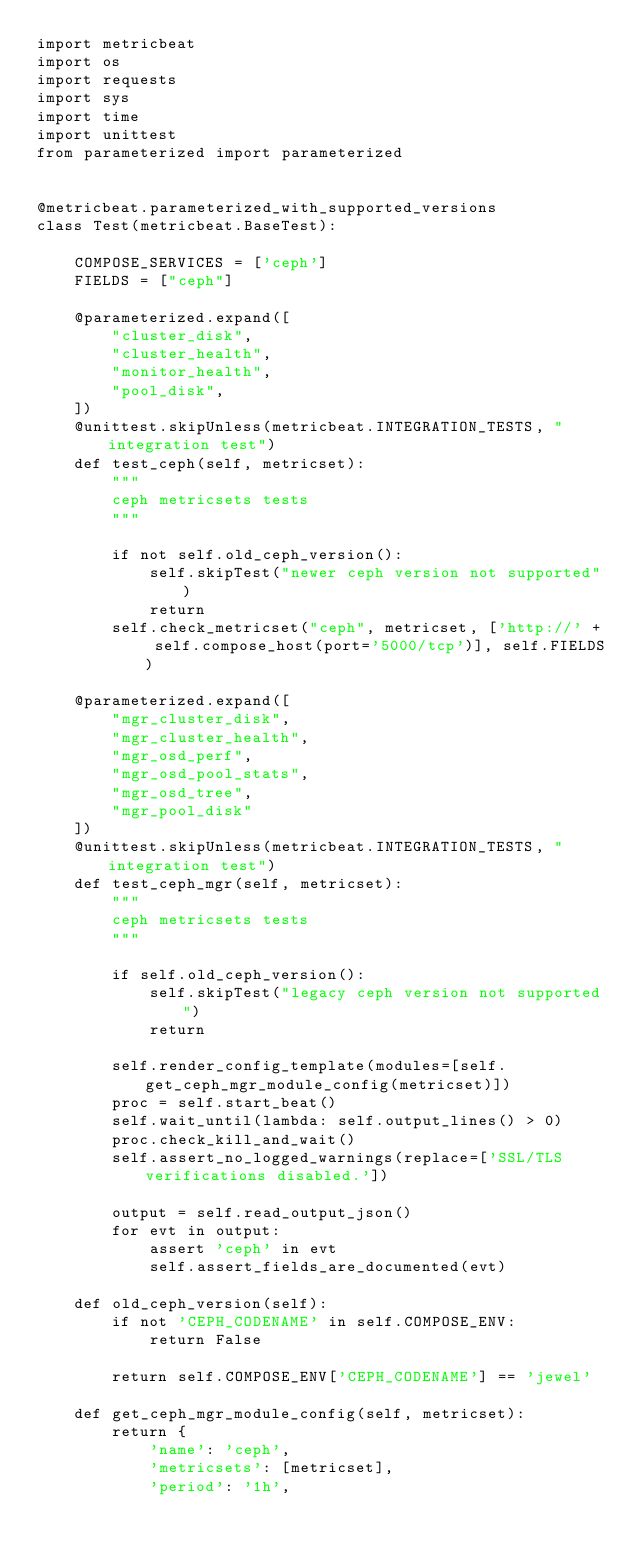Convert code to text. <code><loc_0><loc_0><loc_500><loc_500><_Python_>import metricbeat
import os
import requests
import sys
import time
import unittest
from parameterized import parameterized


@metricbeat.parameterized_with_supported_versions
class Test(metricbeat.BaseTest):

    COMPOSE_SERVICES = ['ceph']
    FIELDS = ["ceph"]

    @parameterized.expand([
        "cluster_disk",
        "cluster_health",
        "monitor_health",
        "pool_disk",
    ])
    @unittest.skipUnless(metricbeat.INTEGRATION_TESTS, "integration test")
    def test_ceph(self, metricset):
        """
        ceph metricsets tests
        """

        if not self.old_ceph_version():
            self.skipTest("newer ceph version not supported")
            return
        self.check_metricset("ceph", metricset, ['http://' + self.compose_host(port='5000/tcp')], self.FIELDS)

    @parameterized.expand([
        "mgr_cluster_disk",
        "mgr_cluster_health",
        "mgr_osd_perf",
        "mgr_osd_pool_stats",
        "mgr_osd_tree",
        "mgr_pool_disk"
    ])
    @unittest.skipUnless(metricbeat.INTEGRATION_TESTS, "integration test")
    def test_ceph_mgr(self, metricset):
        """
        ceph metricsets tests
        """

        if self.old_ceph_version():
            self.skipTest("legacy ceph version not supported")
            return

        self.render_config_template(modules=[self.get_ceph_mgr_module_config(metricset)])
        proc = self.start_beat()
        self.wait_until(lambda: self.output_lines() > 0)
        proc.check_kill_and_wait()
        self.assert_no_logged_warnings(replace=['SSL/TLS verifications disabled.'])

        output = self.read_output_json()
        for evt in output:
            assert 'ceph' in evt
            self.assert_fields_are_documented(evt)

    def old_ceph_version(self):
        if not 'CEPH_CODENAME' in self.COMPOSE_ENV:
            return False

        return self.COMPOSE_ENV['CEPH_CODENAME'] == 'jewel'

    def get_ceph_mgr_module_config(self, metricset):
        return {
            'name': 'ceph',
            'metricsets': [metricset],
            'period': '1h',</code> 